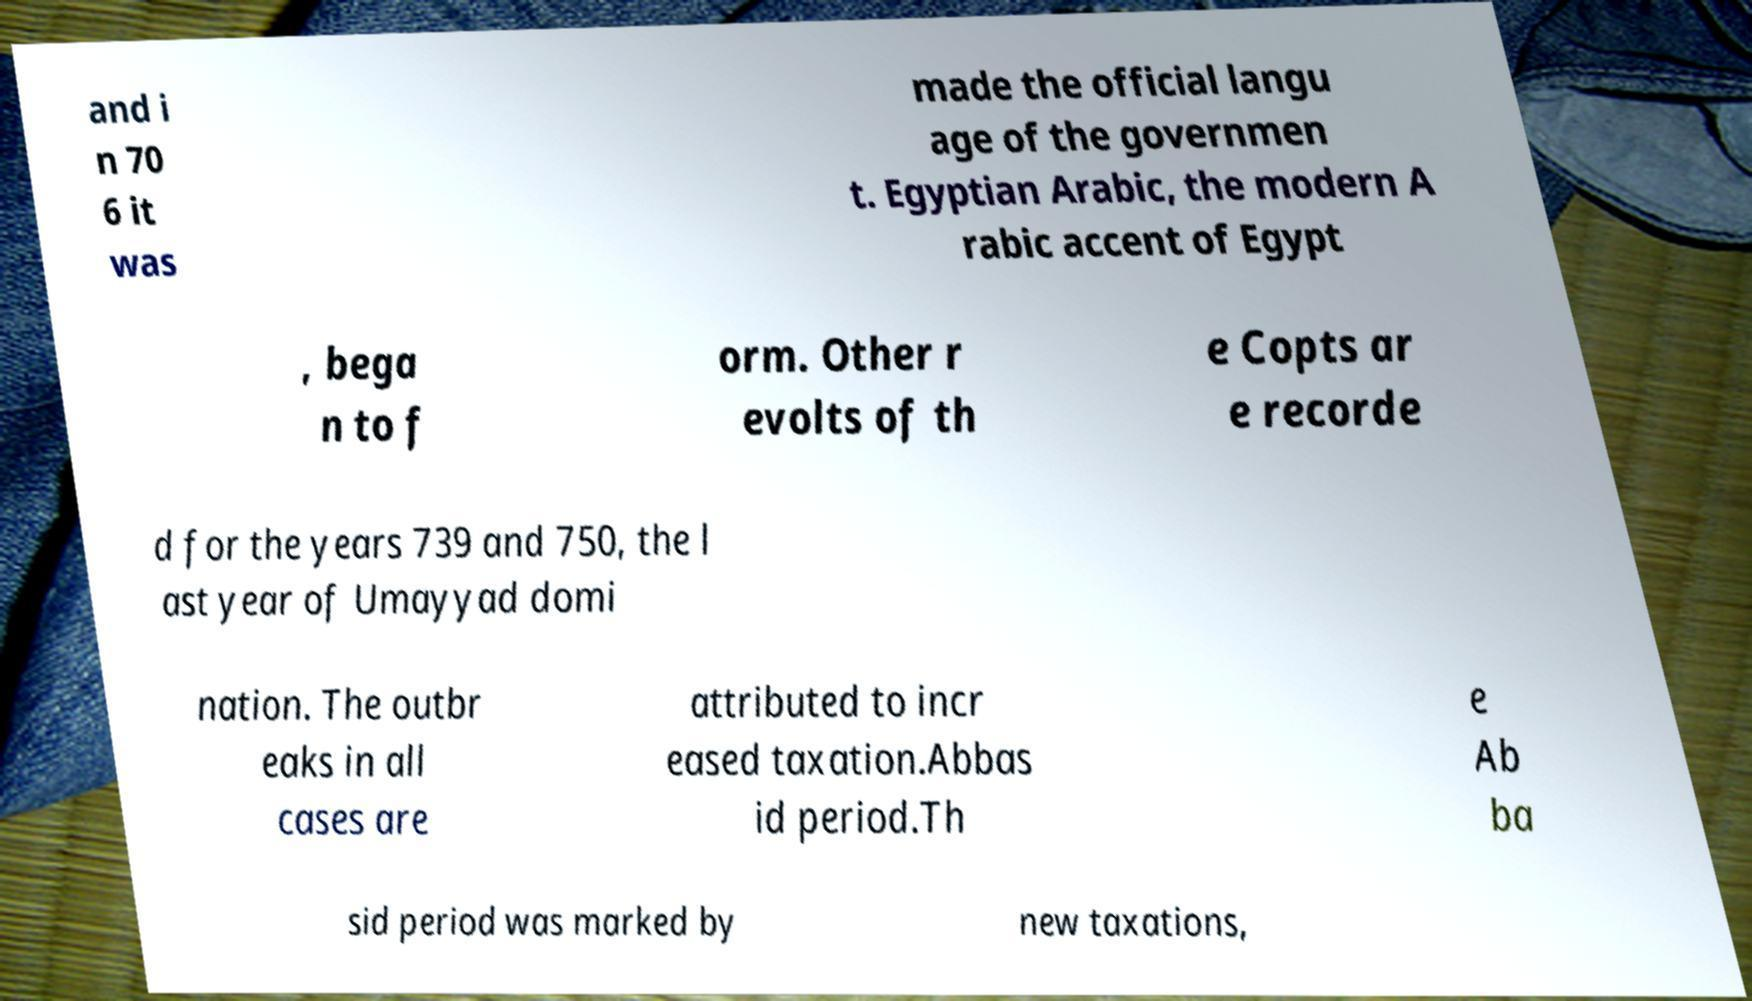For documentation purposes, I need the text within this image transcribed. Could you provide that? and i n 70 6 it was made the official langu age of the governmen t. Egyptian Arabic, the modern A rabic accent of Egypt , bega n to f orm. Other r evolts of th e Copts ar e recorde d for the years 739 and 750, the l ast year of Umayyad domi nation. The outbr eaks in all cases are attributed to incr eased taxation.Abbas id period.Th e Ab ba sid period was marked by new taxations, 